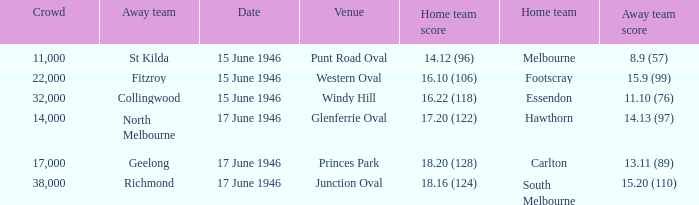On what date was a game played at Windy Hill? 15 June 1946. 